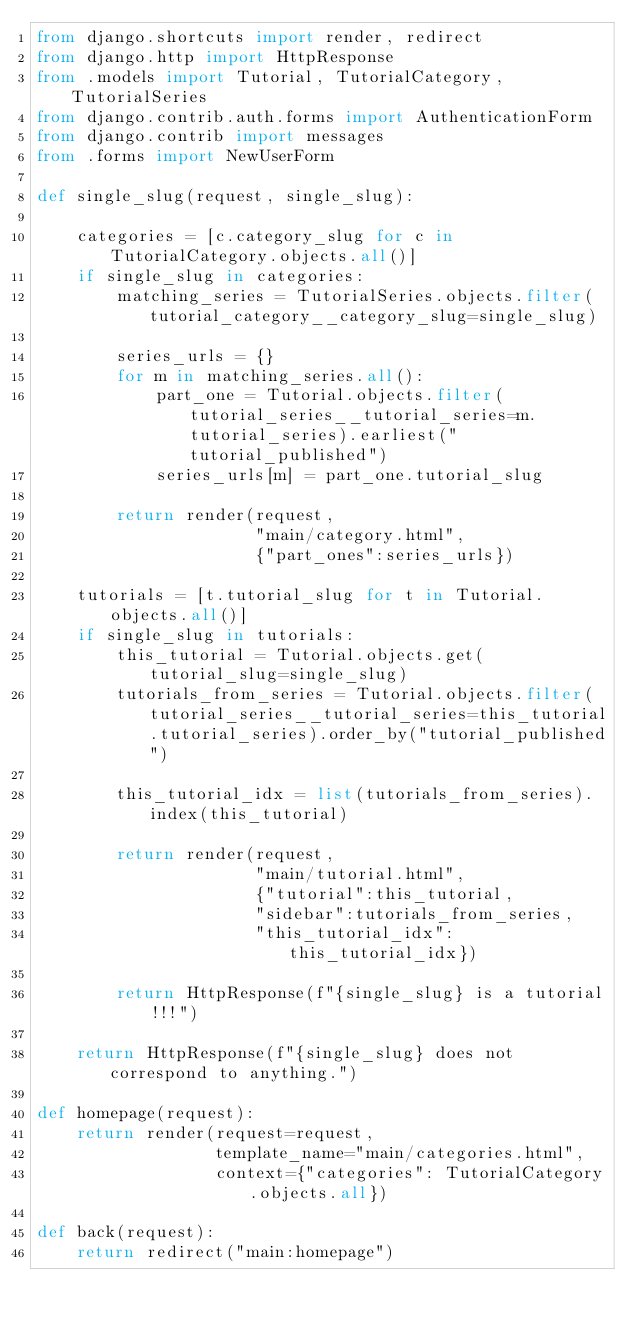<code> <loc_0><loc_0><loc_500><loc_500><_Python_>from django.shortcuts import render, redirect
from django.http import HttpResponse
from .models import Tutorial, TutorialCategory, TutorialSeries
from django.contrib.auth.forms import AuthenticationForm
from django.contrib import messages
from .forms import NewUserForm

def single_slug(request, single_slug):

	categories = [c.category_slug for c in TutorialCategory.objects.all()]
	if single_slug in categories:
		matching_series = TutorialSeries.objects.filter(tutorial_category__category_slug=single_slug)
		
		series_urls = {}
		for m in matching_series.all():
			part_one = Tutorial.objects.filter(tutorial_series__tutorial_series=m.tutorial_series).earliest("tutorial_published")
			series_urls[m] = part_one.tutorial_slug

		return render(request,
					  "main/category.html",
					  {"part_ones":series_urls})

	tutorials = [t.tutorial_slug for t in Tutorial.objects.all()]
	if single_slug in tutorials:
		this_tutorial = Tutorial.objects.get(tutorial_slug=single_slug)
		tutorials_from_series = Tutorial.objects.filter(tutorial_series__tutorial_series=this_tutorial.tutorial_series).order_by("tutorial_published")

		this_tutorial_idx = list(tutorials_from_series).index(this_tutorial)

		return render(request,
					  "main/tutorial.html",
					  {"tutorial":this_tutorial,
					  "sidebar":tutorials_from_series,
					  "this_tutorial_idx":this_tutorial_idx})

		return HttpResponse(f"{single_slug} is a tutorial!!!")

	return HttpResponse(f"{single_slug} does not correspond to anything.")

def homepage(request):
	return render(request=request,
				  template_name="main/categories.html",
				  context={"categories": TutorialCategory.objects.all})
	
def back(request):
	return redirect("main:homepage")</code> 